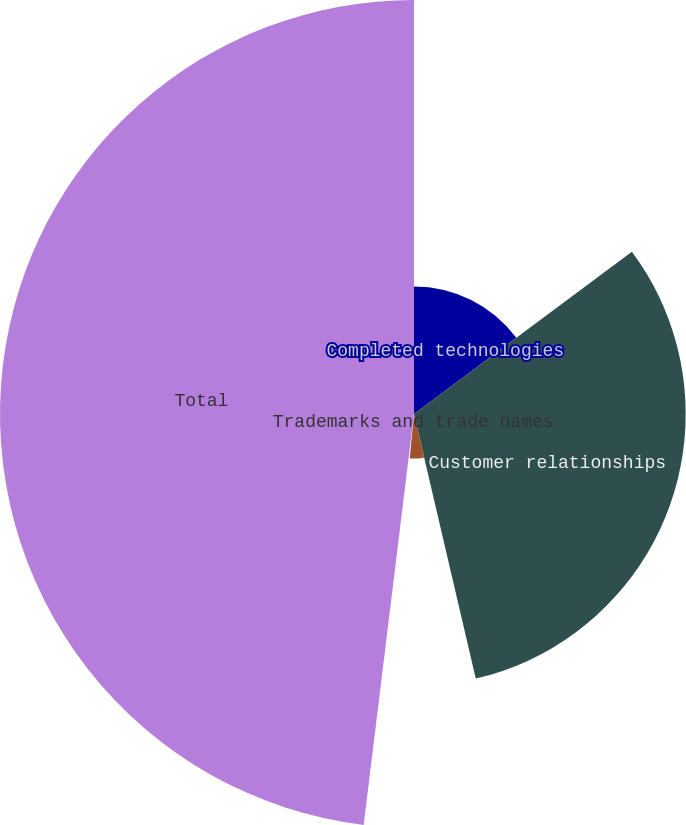Convert chart to OTSL. <chart><loc_0><loc_0><loc_500><loc_500><pie_chart><fcel>Completed technologies<fcel>Customer relationships<fcel>Non-compete agreements<fcel>Trademarks and trade names<fcel>Total<nl><fcel>14.81%<fcel>31.54%<fcel>5.18%<fcel>0.41%<fcel>48.06%<nl></chart> 